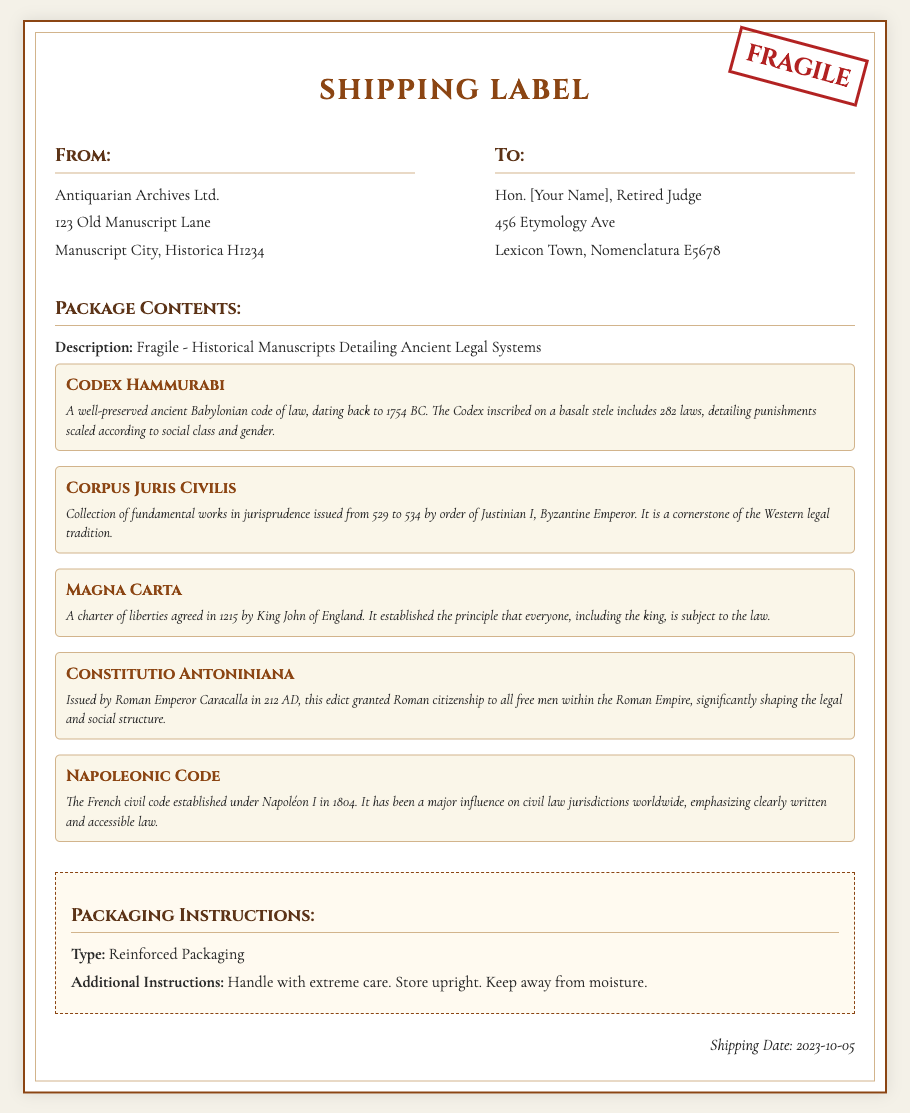What is the sender's name? The sender is Antiquarian Archives Ltd., as specified in the address section of the shipping label.
Answer: Antiquarian Archives Ltd What is the recipient's address? The shipping label specifies the recipient's address, which includes the name, street address, town, and postal code.
Answer: 456 Etymology Ave, Lexicon Town, Nomenclatura E5678 What is the shipping date? The date is clearly indicated in the document as the date on which the item is being shipped.
Answer: 2023-10-05 What is the packaging type for the manuscripts? The shipping label includes a section detailing the packaging instructions, which identifies how the manuscripts should be packed.
Answer: Reinforced Packaging How many manuscripts are listed? The package contents section enumerates the manuscripts, allowing one to count the number of entries provided.
Answer: Five What is the title of the first manuscript? The first manuscript title in the list is specifically noted in the document, presenting both the title and a description.
Answer: Codex Hammurabi What is the primary color of the fragile stamp? The fragile stamp's color is described in the document, and this color is significant for indicating care during transport.
Answer: Red What type of care instructions are provided? The instructions highlight the necessities for handling the package, specifying aspects of care.
Answer: Handle with extreme care What ancient legal system is associated with the Magna Carta? The description notes a specific historical context related to this manuscript, linking it to a specific legal tradition.
Answer: King John of England 